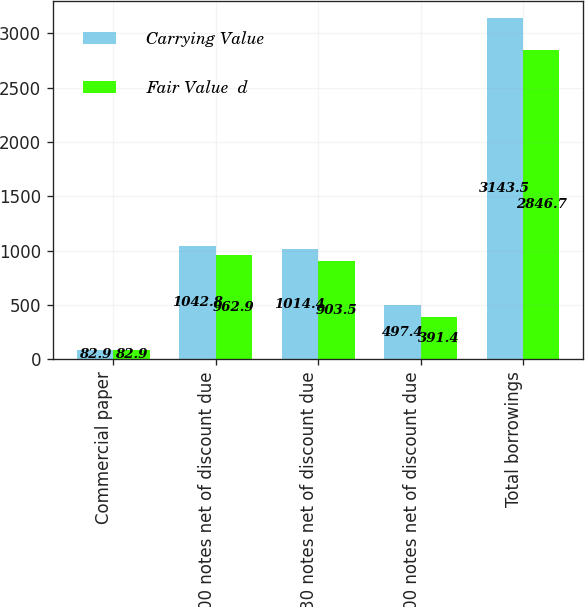Convert chart. <chart><loc_0><loc_0><loc_500><loc_500><stacked_bar_chart><ecel><fcel>Commercial paper<fcel>5400 notes net of discount due<fcel>5930 notes net of discount due<fcel>6200 notes net of discount due<fcel>Total borrowings<nl><fcel>Carrying Value<fcel>82.9<fcel>1042.8<fcel>1014.4<fcel>497.4<fcel>3143.5<nl><fcel>Fair Value  d<fcel>82.9<fcel>962.9<fcel>903.5<fcel>391.4<fcel>2846.7<nl></chart> 